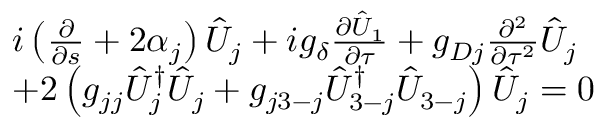Convert formula to latex. <formula><loc_0><loc_0><loc_500><loc_500>\begin{array} { r l } & { i \left ( \frac { \partial } { \partial s } + 2 \alpha _ { j } \right ) \hat { U } _ { j } + i g _ { \delta } \frac { \partial \hat { U } _ { 1 } } { \partial \tau } + g _ { D j } \frac { \partial ^ { 2 } } { \partial \tau ^ { 2 } } \hat { U } _ { j } } \\ & { + 2 \left ( g _ { j j } \hat { U } _ { j } ^ { \dag } \hat { U } _ { j } + g _ { j 3 - j } \hat { U } _ { 3 - j } ^ { \dagger } \hat { U } _ { 3 - j } \right ) \hat { U } _ { j } = 0 } \end{array}</formula> 